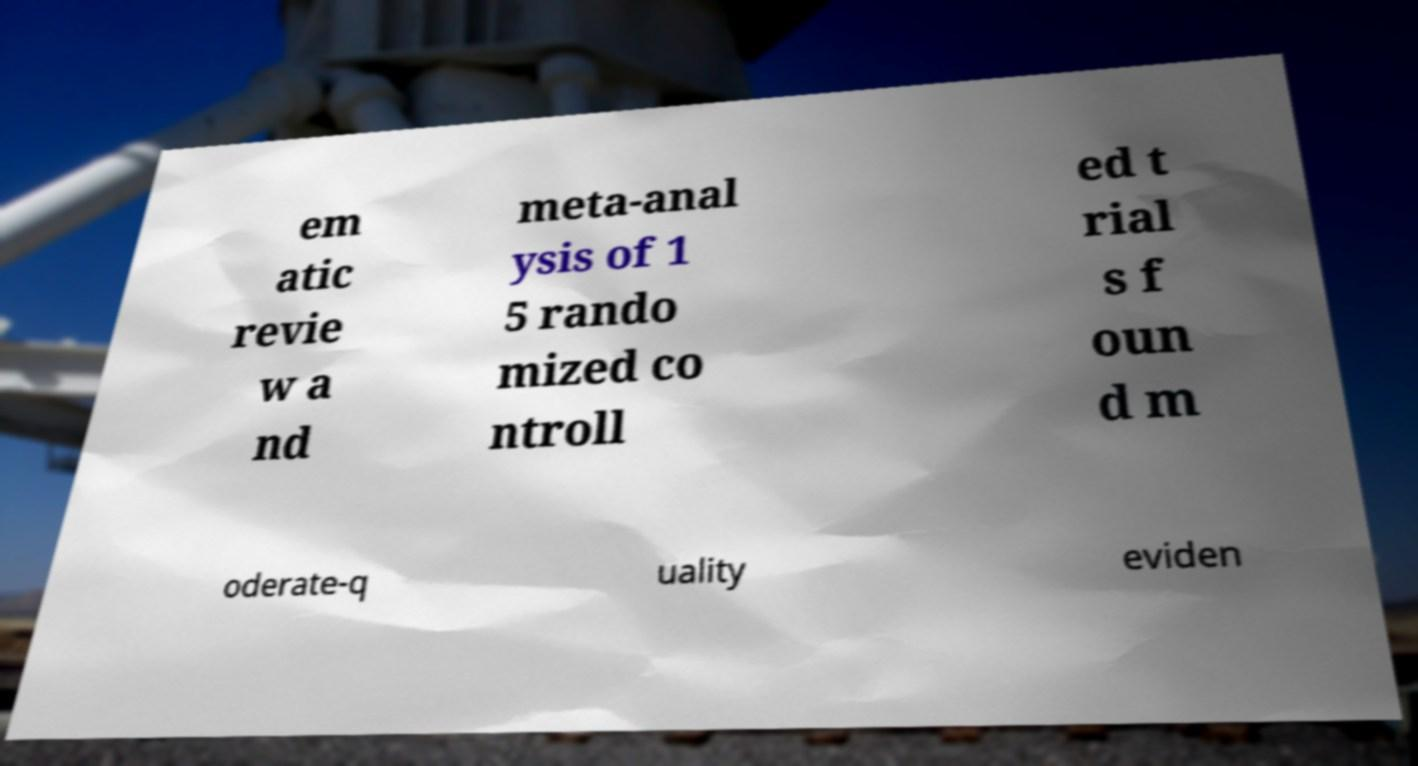There's text embedded in this image that I need extracted. Can you transcribe it verbatim? em atic revie w a nd meta-anal ysis of 1 5 rando mized co ntroll ed t rial s f oun d m oderate-q uality eviden 